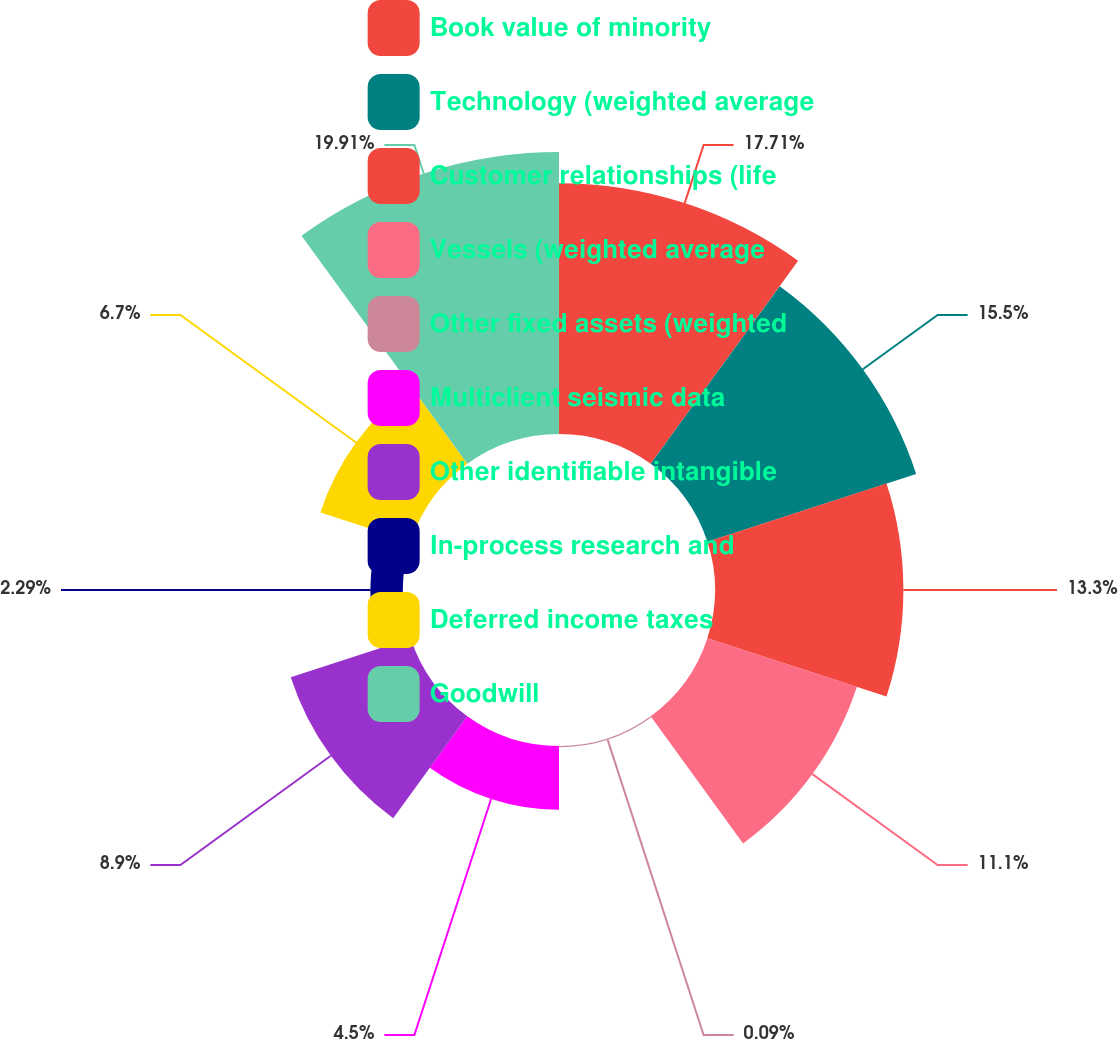<chart> <loc_0><loc_0><loc_500><loc_500><pie_chart><fcel>Book value of minority<fcel>Technology (weighted average<fcel>Customer relationships (life<fcel>Vessels (weighted average<fcel>Other fixed assets (weighted<fcel>Multiclient seismic data<fcel>Other identifiable intangible<fcel>In-process research and<fcel>Deferred income taxes<fcel>Goodwill<nl><fcel>17.71%<fcel>15.5%<fcel>13.3%<fcel>11.1%<fcel>0.09%<fcel>4.5%<fcel>8.9%<fcel>2.29%<fcel>6.7%<fcel>19.91%<nl></chart> 